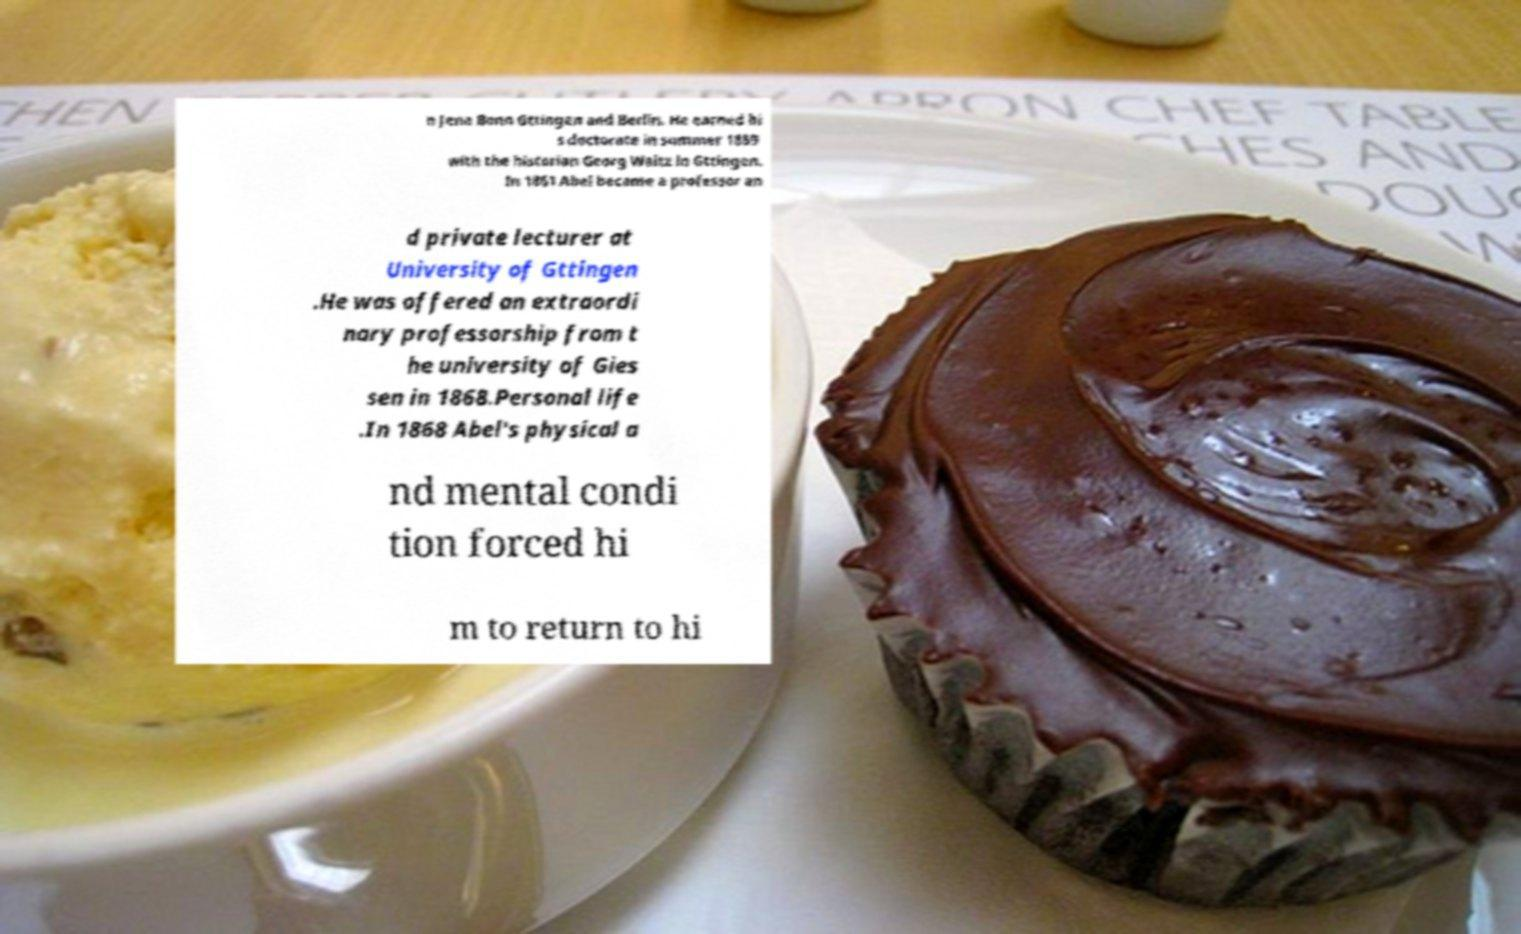Please read and relay the text visible in this image. What does it say? n Jena Bonn Gttingen and Berlin. He earned hi s doctorate in summer 1859 with the historian Georg Waitz in Gttingen. In 1861 Abel became a professor an d private lecturer at University of Gttingen .He was offered an extraordi nary professorship from t he university of Gies sen in 1868.Personal life .In 1868 Abel's physical a nd mental condi tion forced hi m to return to hi 